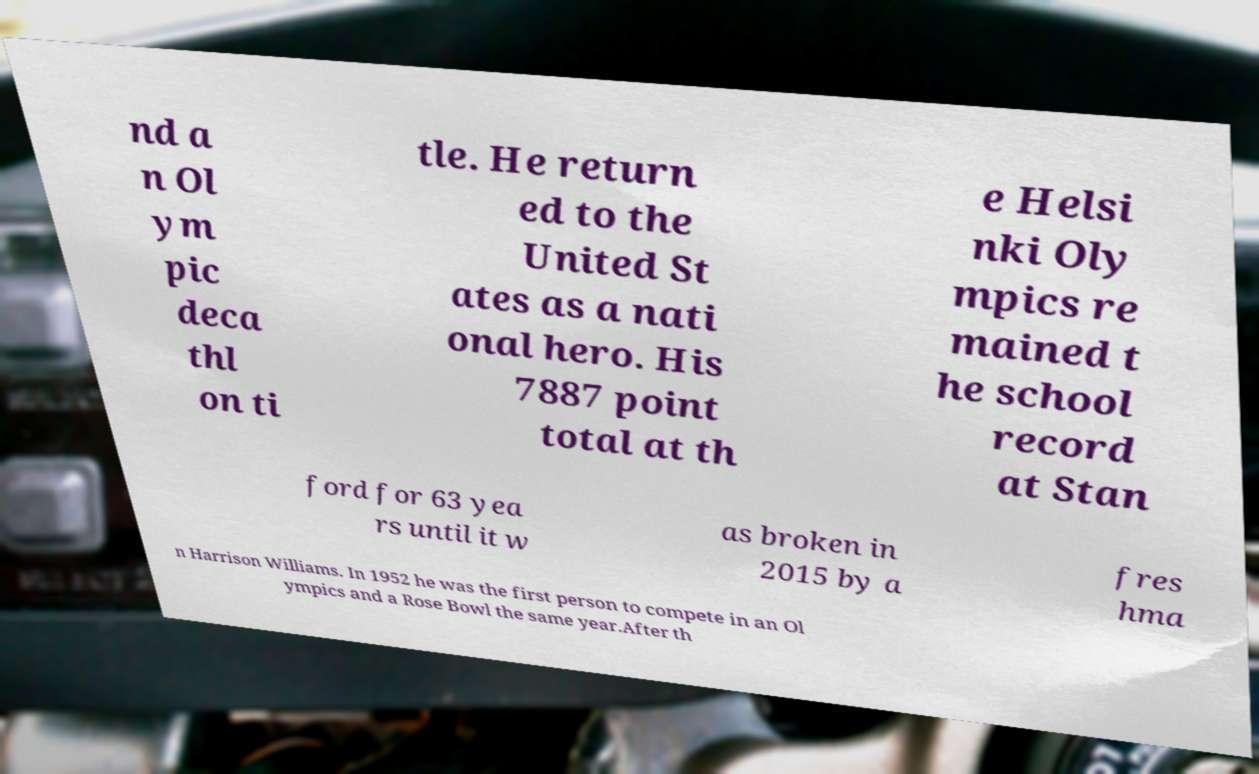I need the written content from this picture converted into text. Can you do that? nd a n Ol ym pic deca thl on ti tle. He return ed to the United St ates as a nati onal hero. His 7887 point total at th e Helsi nki Oly mpics re mained t he school record at Stan ford for 63 yea rs until it w as broken in 2015 by a fres hma n Harrison Williams. In 1952 he was the first person to compete in an Ol ympics and a Rose Bowl the same year.After th 